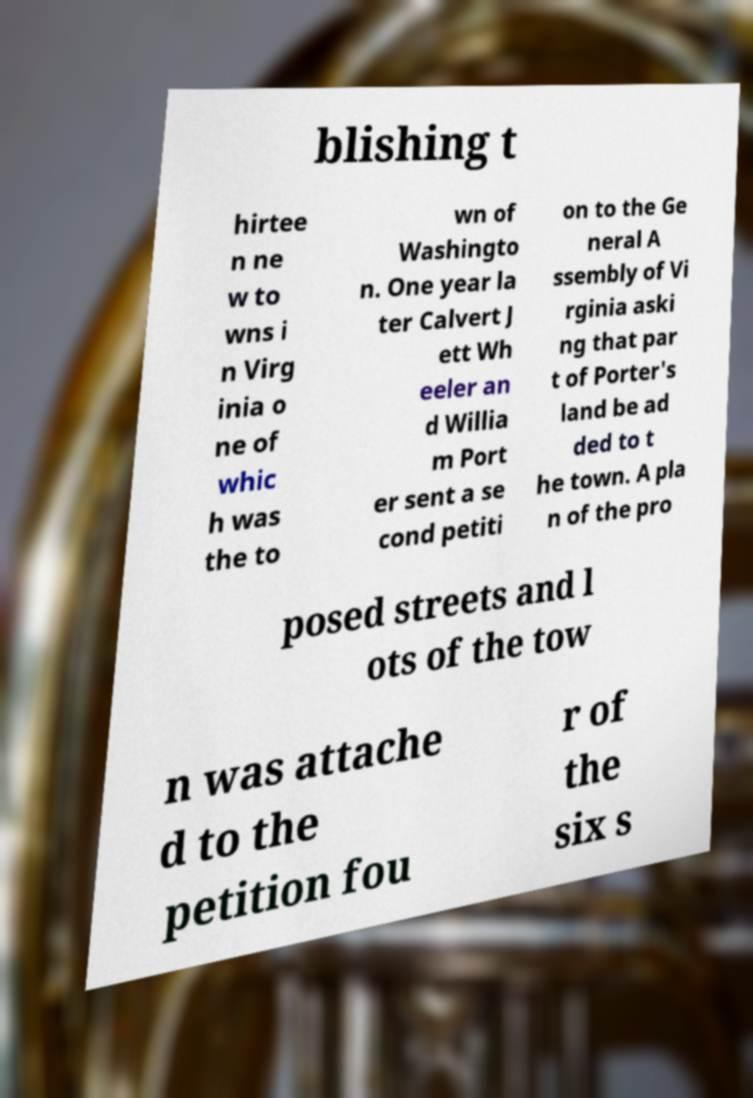There's text embedded in this image that I need extracted. Can you transcribe it verbatim? blishing t hirtee n ne w to wns i n Virg inia o ne of whic h was the to wn of Washingto n. One year la ter Calvert J ett Wh eeler an d Willia m Port er sent a se cond petiti on to the Ge neral A ssembly of Vi rginia aski ng that par t of Porter's land be ad ded to t he town. A pla n of the pro posed streets and l ots of the tow n was attache d to the petition fou r of the six s 